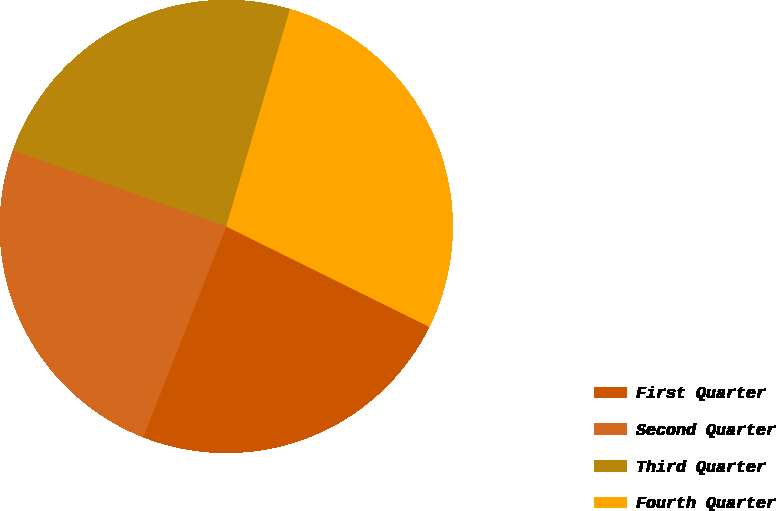<chart> <loc_0><loc_0><loc_500><loc_500><pie_chart><fcel>First Quarter<fcel>Second Quarter<fcel>Third Quarter<fcel>Fourth Quarter<nl><fcel>23.67%<fcel>24.49%<fcel>24.08%<fcel>27.77%<nl></chart> 